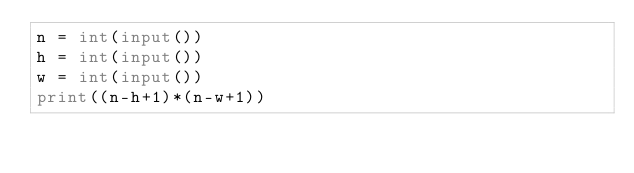<code> <loc_0><loc_0><loc_500><loc_500><_Python_>n = int(input())
h = int(input())
w = int(input())
print((n-h+1)*(n-w+1))</code> 